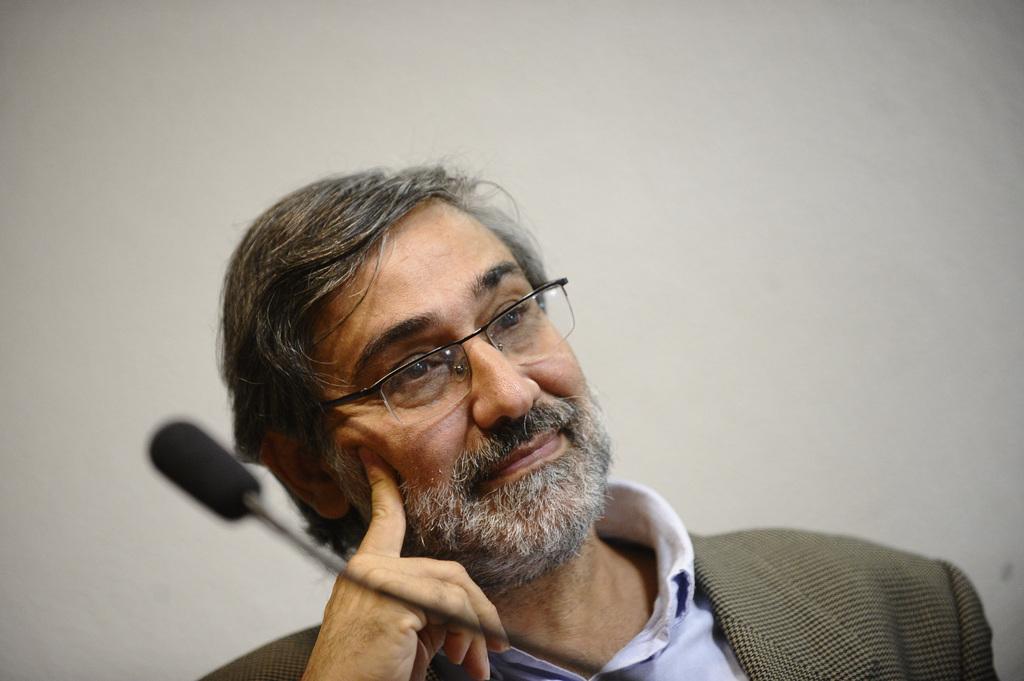How would you summarize this image in a sentence or two? In this image I can see the person and the person is wearing brown color blazer. In front I can see the microphone. In the background the wall is in cream color. 